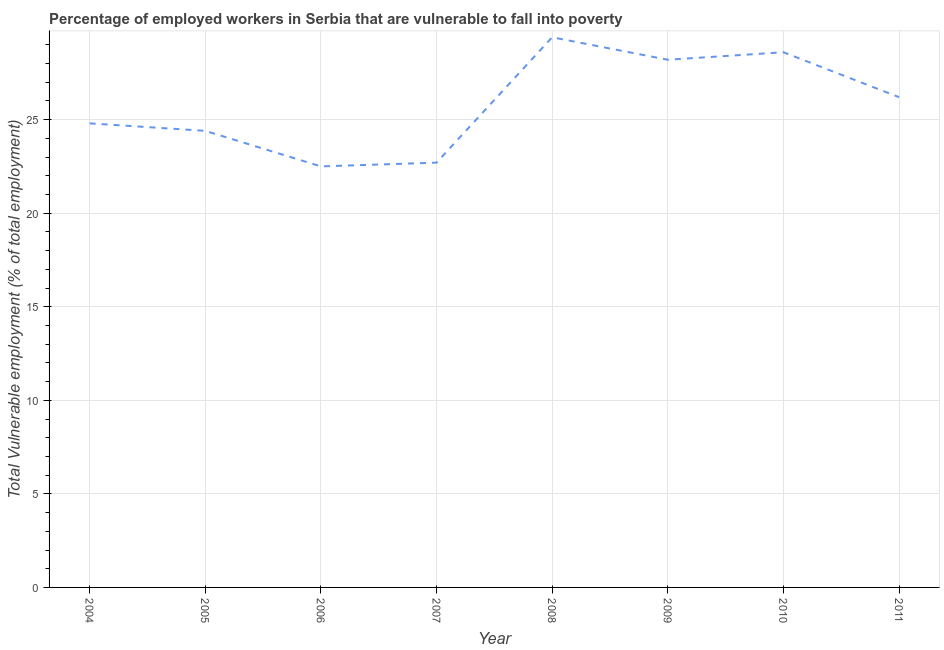What is the total vulnerable employment in 2006?
Provide a short and direct response. 22.5. Across all years, what is the maximum total vulnerable employment?
Make the answer very short. 29.4. In which year was the total vulnerable employment maximum?
Your answer should be compact. 2008. In which year was the total vulnerable employment minimum?
Provide a succinct answer. 2006. What is the sum of the total vulnerable employment?
Provide a succinct answer. 206.8. What is the difference between the total vulnerable employment in 2004 and 2005?
Ensure brevity in your answer.  0.4. What is the average total vulnerable employment per year?
Offer a terse response. 25.85. What is the median total vulnerable employment?
Make the answer very short. 25.5. In how many years, is the total vulnerable employment greater than 20 %?
Your response must be concise. 8. Do a majority of the years between 2009 and 2004 (inclusive) have total vulnerable employment greater than 14 %?
Ensure brevity in your answer.  Yes. What is the ratio of the total vulnerable employment in 2005 to that in 2007?
Offer a terse response. 1.07. Is the total vulnerable employment in 2005 less than that in 2007?
Give a very brief answer. No. Is the difference between the total vulnerable employment in 2007 and 2009 greater than the difference between any two years?
Your answer should be very brief. No. What is the difference between the highest and the second highest total vulnerable employment?
Make the answer very short. 0.8. Is the sum of the total vulnerable employment in 2005 and 2011 greater than the maximum total vulnerable employment across all years?
Your response must be concise. Yes. What is the difference between the highest and the lowest total vulnerable employment?
Offer a very short reply. 6.9. Does the total vulnerable employment monotonically increase over the years?
Keep it short and to the point. No. What is the title of the graph?
Give a very brief answer. Percentage of employed workers in Serbia that are vulnerable to fall into poverty. What is the label or title of the Y-axis?
Provide a short and direct response. Total Vulnerable employment (% of total employment). What is the Total Vulnerable employment (% of total employment) of 2004?
Offer a very short reply. 24.8. What is the Total Vulnerable employment (% of total employment) of 2005?
Offer a terse response. 24.4. What is the Total Vulnerable employment (% of total employment) in 2007?
Offer a terse response. 22.7. What is the Total Vulnerable employment (% of total employment) in 2008?
Provide a succinct answer. 29.4. What is the Total Vulnerable employment (% of total employment) of 2009?
Make the answer very short. 28.2. What is the Total Vulnerable employment (% of total employment) of 2010?
Offer a very short reply. 28.6. What is the Total Vulnerable employment (% of total employment) in 2011?
Ensure brevity in your answer.  26.2. What is the difference between the Total Vulnerable employment (% of total employment) in 2004 and 2005?
Ensure brevity in your answer.  0.4. What is the difference between the Total Vulnerable employment (% of total employment) in 2004 and 2009?
Provide a short and direct response. -3.4. What is the difference between the Total Vulnerable employment (% of total employment) in 2004 and 2011?
Your answer should be compact. -1.4. What is the difference between the Total Vulnerable employment (% of total employment) in 2005 and 2010?
Make the answer very short. -4.2. What is the difference between the Total Vulnerable employment (% of total employment) in 2005 and 2011?
Ensure brevity in your answer.  -1.8. What is the difference between the Total Vulnerable employment (% of total employment) in 2006 and 2007?
Your response must be concise. -0.2. What is the difference between the Total Vulnerable employment (% of total employment) in 2006 and 2008?
Provide a short and direct response. -6.9. What is the difference between the Total Vulnerable employment (% of total employment) in 2006 and 2009?
Offer a terse response. -5.7. What is the difference between the Total Vulnerable employment (% of total employment) in 2006 and 2010?
Provide a succinct answer. -6.1. What is the difference between the Total Vulnerable employment (% of total employment) in 2006 and 2011?
Offer a terse response. -3.7. What is the difference between the Total Vulnerable employment (% of total employment) in 2007 and 2010?
Give a very brief answer. -5.9. What is the difference between the Total Vulnerable employment (% of total employment) in 2008 and 2011?
Ensure brevity in your answer.  3.2. What is the difference between the Total Vulnerable employment (% of total employment) in 2010 and 2011?
Keep it short and to the point. 2.4. What is the ratio of the Total Vulnerable employment (% of total employment) in 2004 to that in 2006?
Your response must be concise. 1.1. What is the ratio of the Total Vulnerable employment (% of total employment) in 2004 to that in 2007?
Ensure brevity in your answer.  1.09. What is the ratio of the Total Vulnerable employment (% of total employment) in 2004 to that in 2008?
Your answer should be very brief. 0.84. What is the ratio of the Total Vulnerable employment (% of total employment) in 2004 to that in 2009?
Ensure brevity in your answer.  0.88. What is the ratio of the Total Vulnerable employment (% of total employment) in 2004 to that in 2010?
Make the answer very short. 0.87. What is the ratio of the Total Vulnerable employment (% of total employment) in 2004 to that in 2011?
Keep it short and to the point. 0.95. What is the ratio of the Total Vulnerable employment (% of total employment) in 2005 to that in 2006?
Make the answer very short. 1.08. What is the ratio of the Total Vulnerable employment (% of total employment) in 2005 to that in 2007?
Provide a short and direct response. 1.07. What is the ratio of the Total Vulnerable employment (% of total employment) in 2005 to that in 2008?
Your answer should be very brief. 0.83. What is the ratio of the Total Vulnerable employment (% of total employment) in 2005 to that in 2009?
Keep it short and to the point. 0.86. What is the ratio of the Total Vulnerable employment (% of total employment) in 2005 to that in 2010?
Offer a terse response. 0.85. What is the ratio of the Total Vulnerable employment (% of total employment) in 2006 to that in 2007?
Give a very brief answer. 0.99. What is the ratio of the Total Vulnerable employment (% of total employment) in 2006 to that in 2008?
Keep it short and to the point. 0.77. What is the ratio of the Total Vulnerable employment (% of total employment) in 2006 to that in 2009?
Offer a terse response. 0.8. What is the ratio of the Total Vulnerable employment (% of total employment) in 2006 to that in 2010?
Your response must be concise. 0.79. What is the ratio of the Total Vulnerable employment (% of total employment) in 2006 to that in 2011?
Ensure brevity in your answer.  0.86. What is the ratio of the Total Vulnerable employment (% of total employment) in 2007 to that in 2008?
Your answer should be compact. 0.77. What is the ratio of the Total Vulnerable employment (% of total employment) in 2007 to that in 2009?
Keep it short and to the point. 0.81. What is the ratio of the Total Vulnerable employment (% of total employment) in 2007 to that in 2010?
Your response must be concise. 0.79. What is the ratio of the Total Vulnerable employment (% of total employment) in 2007 to that in 2011?
Your answer should be very brief. 0.87. What is the ratio of the Total Vulnerable employment (% of total employment) in 2008 to that in 2009?
Make the answer very short. 1.04. What is the ratio of the Total Vulnerable employment (% of total employment) in 2008 to that in 2010?
Keep it short and to the point. 1.03. What is the ratio of the Total Vulnerable employment (% of total employment) in 2008 to that in 2011?
Provide a succinct answer. 1.12. What is the ratio of the Total Vulnerable employment (% of total employment) in 2009 to that in 2011?
Keep it short and to the point. 1.08. What is the ratio of the Total Vulnerable employment (% of total employment) in 2010 to that in 2011?
Your response must be concise. 1.09. 